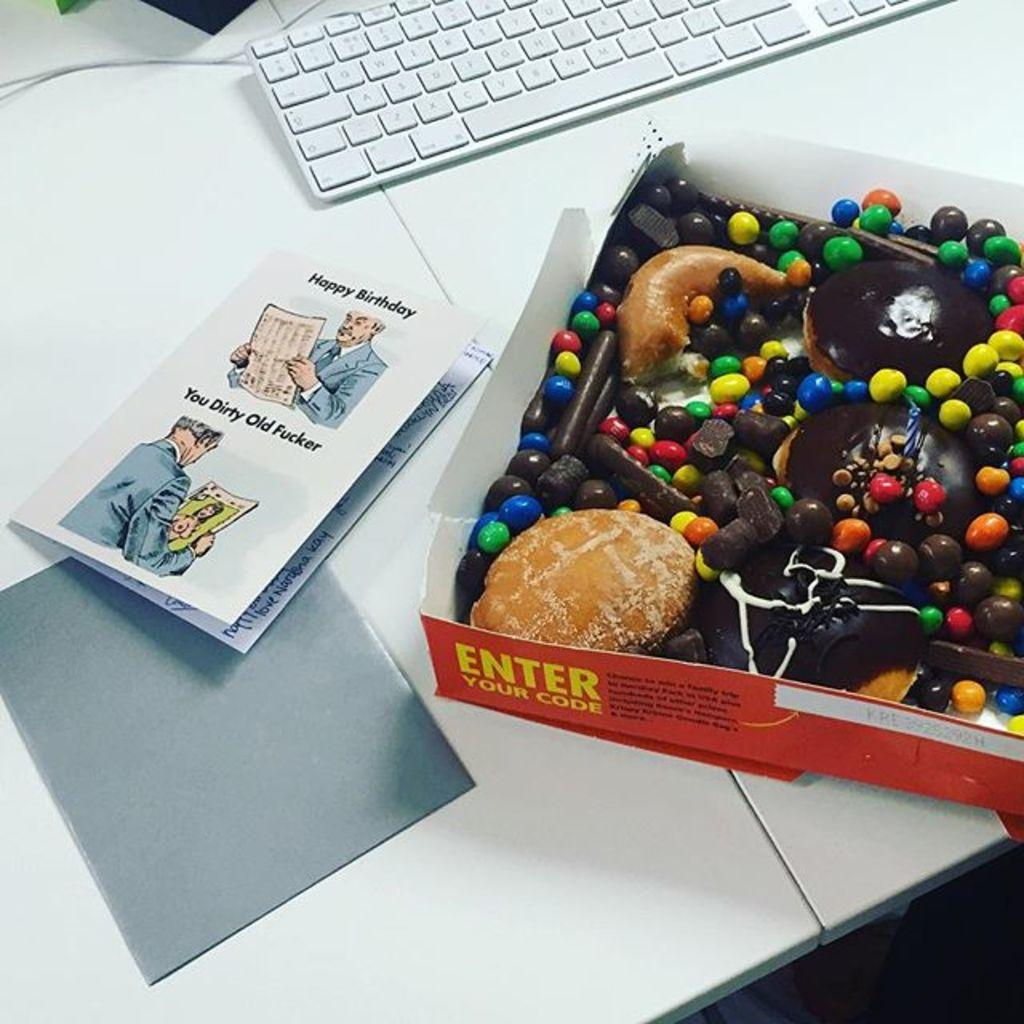<image>
Describe the image concisely. The card with two men on it and it's for a birthday 